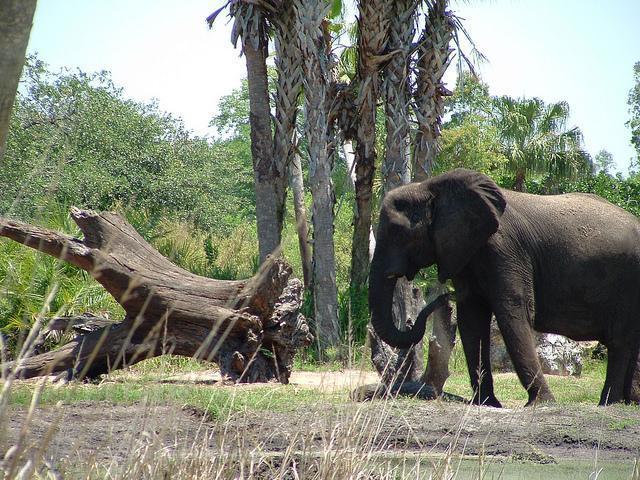How many trees are laying on the ground?
Give a very brief answer. 1. How many elephants are near the log?
Give a very brief answer. 1. 